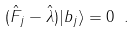Convert formula to latex. <formula><loc_0><loc_0><loc_500><loc_500>( \hat { F } _ { j } - \hat { \lambda } ) | b _ { j } \rangle = 0 \ .</formula> 